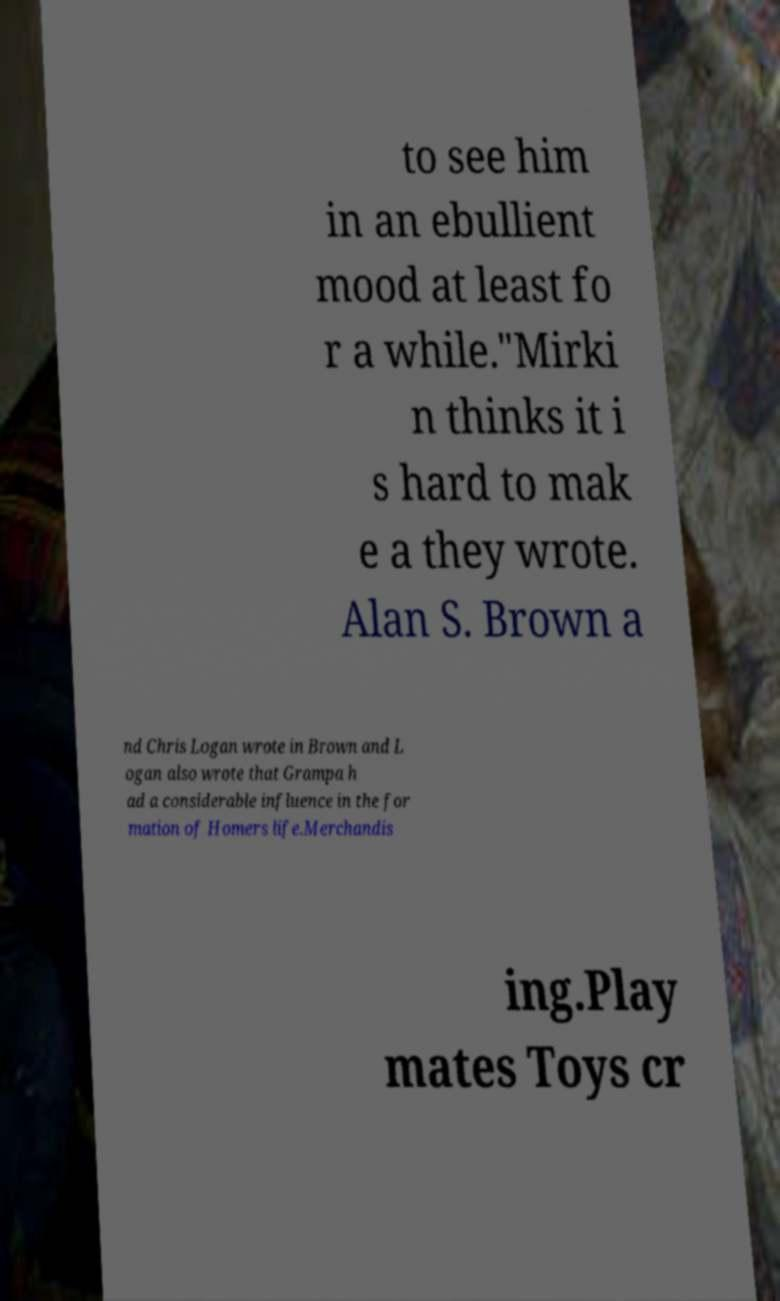Please read and relay the text visible in this image. What does it say? to see him in an ebullient mood at least fo r a while."Mirki n thinks it i s hard to mak e a they wrote. Alan S. Brown a nd Chris Logan wrote in Brown and L ogan also wrote that Grampa h ad a considerable influence in the for mation of Homers life.Merchandis ing.Play mates Toys cr 